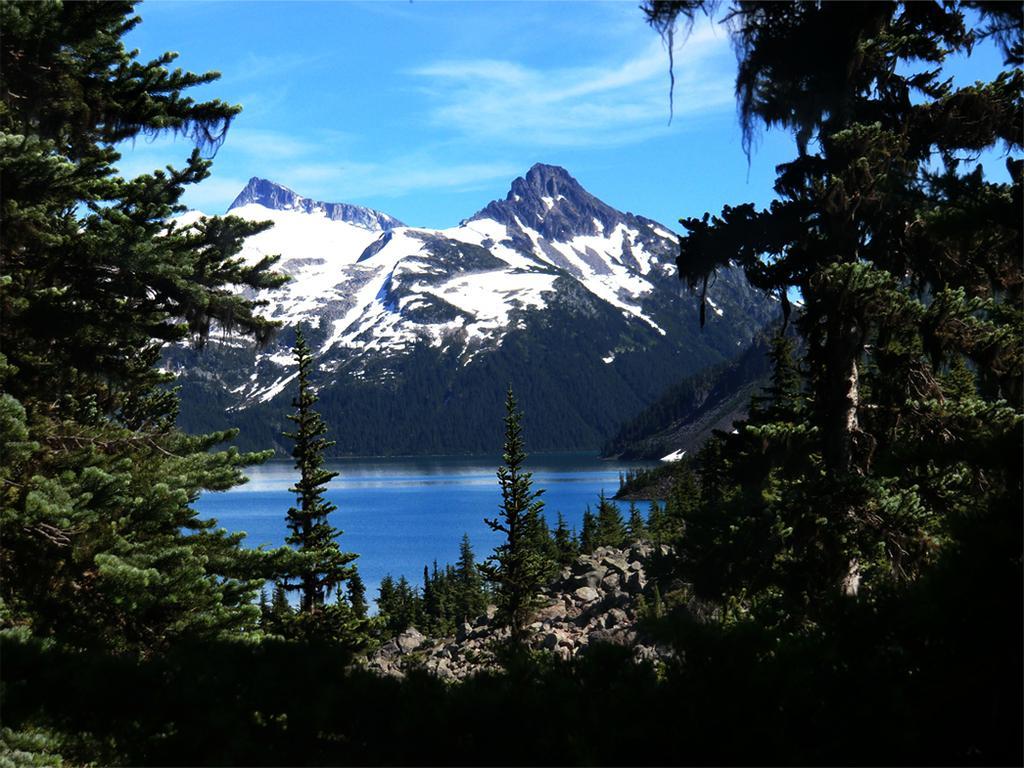Please provide a concise description of this image. In this image we can see few mountains. There is a blue and a slightly cloudy sky in the image. There are many trees in the image. There are many rocks in the image. There is a lake in the image. 